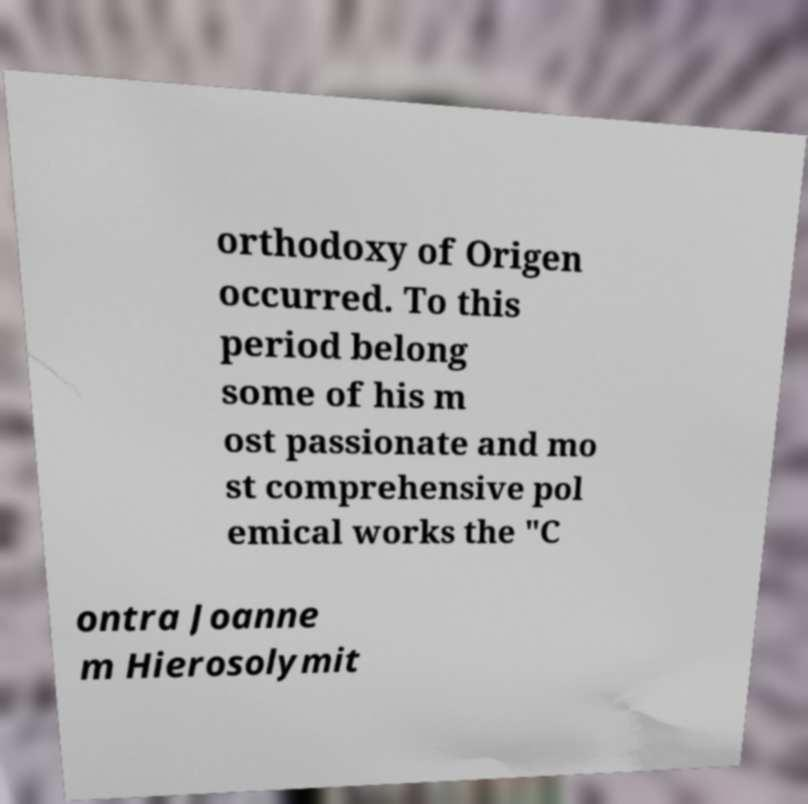For documentation purposes, I need the text within this image transcribed. Could you provide that? orthodoxy of Origen occurred. To this period belong some of his m ost passionate and mo st comprehensive pol emical works the "C ontra Joanne m Hierosolymit 